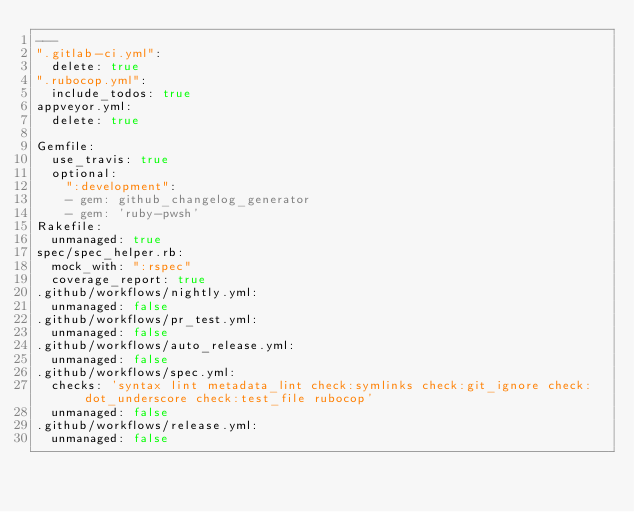<code> <loc_0><loc_0><loc_500><loc_500><_YAML_>---
".gitlab-ci.yml":
  delete: true
".rubocop.yml":
  include_todos: true
appveyor.yml:
  delete: true

Gemfile:
  use_travis: true
  optional:
    ":development":
    - gem: github_changelog_generator
    - gem: 'ruby-pwsh'
Rakefile:
  unmanaged: true
spec/spec_helper.rb:
  mock_with: ":rspec"
  coverage_report: true
.github/workflows/nightly.yml:
  unmanaged: false
.github/workflows/pr_test.yml:
  unmanaged: false
.github/workflows/auto_release.yml:
  unmanaged: false
.github/workflows/spec.yml:
  checks: 'syntax lint metadata_lint check:symlinks check:git_ignore check:dot_underscore check:test_file rubocop'
  unmanaged: false
.github/workflows/release.yml:
  unmanaged: false</code> 